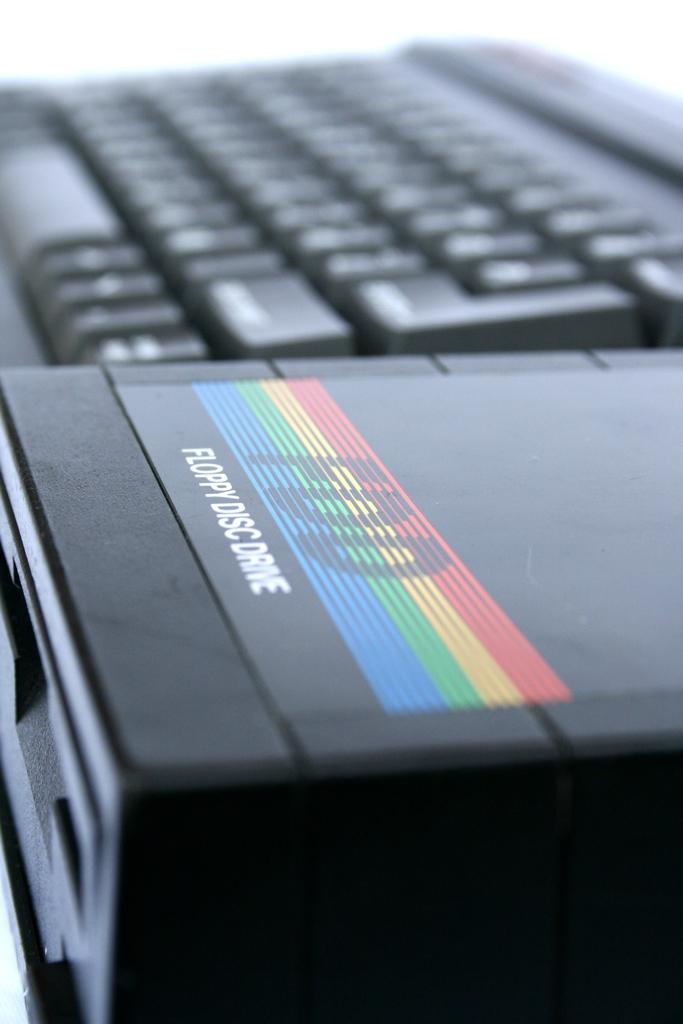Provide a one-sentence caption for the provided image. A floppy disc drive sits next to a computer keyboard. 